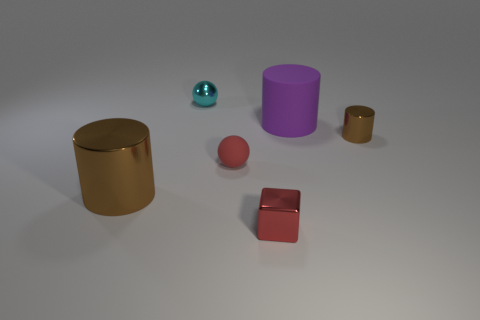Do the small metal cylinder and the large metal cylinder have the same color?
Provide a short and direct response. Yes. There is a cylinder that is in front of the big matte thing and right of the big brown thing; how big is it?
Provide a succinct answer. Small. What number of red cubes are the same size as the cyan sphere?
Keep it short and to the point. 1. What material is the sphere that is the same color as the tiny block?
Provide a short and direct response. Rubber. There is a brown thing that is to the right of the small rubber ball; is it the same shape as the large brown metallic thing?
Give a very brief answer. Yes. Are there fewer small objects that are behind the big brown cylinder than small objects?
Offer a terse response. Yes. Is there a metal block that has the same color as the tiny matte sphere?
Provide a succinct answer. Yes. Do the large purple matte thing and the brown shiny thing to the right of the big metal thing have the same shape?
Provide a succinct answer. Yes. Is there a large red object made of the same material as the purple thing?
Provide a short and direct response. No. There is a cylinder that is left of the thing that is behind the purple object; are there any brown cylinders that are behind it?
Ensure brevity in your answer.  Yes. 